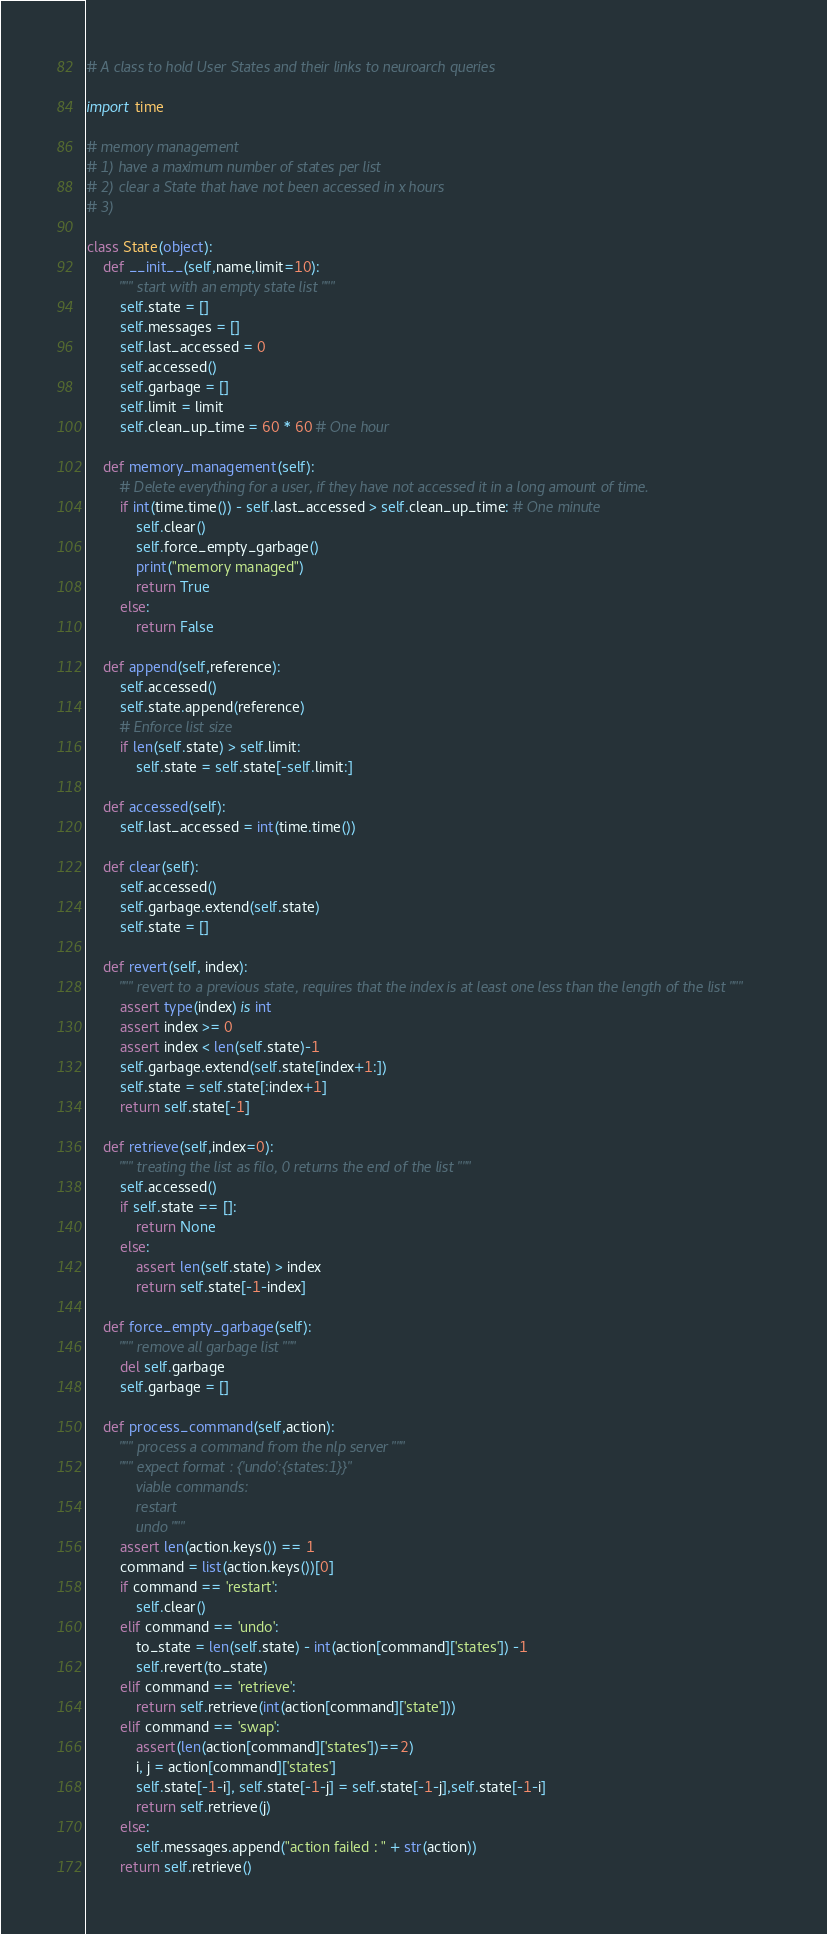Convert code to text. <code><loc_0><loc_0><loc_500><loc_500><_Python_># A class to hold User States and their links to neuroarch queries

import time

# memory management
# 1) have a maximum number of states per list
# 2) clear a State that have not been accessed in x hours
# 3)

class State(object):
    def __init__(self,name,limit=10):
        """ start with an empty state list """
        self.state = []
        self.messages = []
        self.last_accessed = 0
        self.accessed()
        self.garbage = []
        self.limit = limit
        self.clean_up_time = 60 * 60 # One hour

    def memory_management(self):
        # Delete everything for a user, if they have not accessed it in a long amount of time.
        if int(time.time()) - self.last_accessed > self.clean_up_time: # One minute
            self.clear()
            self.force_empty_garbage()
            print("memory managed")
            return True
        else:
            return False

    def append(self,reference):
        self.accessed()
        self.state.append(reference)
        # Enforce list size
        if len(self.state) > self.limit:
            self.state = self.state[-self.limit:]

    def accessed(self):
        self.last_accessed = int(time.time())

    def clear(self):
        self.accessed()
        self.garbage.extend(self.state)
        self.state = []

    def revert(self, index):
        """ revert to a previous state, requires that the index is at least one less than the length of the list """
        assert type(index) is int
        assert index >= 0
        assert index < len(self.state)-1
        self.garbage.extend(self.state[index+1:])
        self.state = self.state[:index+1]
        return self.state[-1]

    def retrieve(self,index=0):
        """ treating the list as filo, 0 returns the end of the list """
        self.accessed()
        if self.state == []:
            return None
        else:
            assert len(self.state) > index
            return self.state[-1-index]

    def force_empty_garbage(self):
        """ remove all garbage list """
        del self.garbage
        self.garbage = []

    def process_command(self,action):
        """ process a command from the nlp server """
        """ expect format : {'undo':{states:1}}"
            viable commands:
            restart
            undo """
        assert len(action.keys()) == 1
        command = list(action.keys())[0]
        if command == 'restart':
            self.clear()
        elif command == 'undo':
            to_state = len(self.state) - int(action[command]['states']) -1
            self.revert(to_state)
        elif command == 'retrieve':
            return self.retrieve(int(action[command]['state']))
        elif command == 'swap':
            assert(len(action[command]['states'])==2)
            i, j = action[command]['states']
            self.state[-1-i], self.state[-1-j] = self.state[-1-j],self.state[-1-i]
            return self.retrieve(j)
        else:
            self.messages.append("action failed : " + str(action))
        return self.retrieve()
</code> 